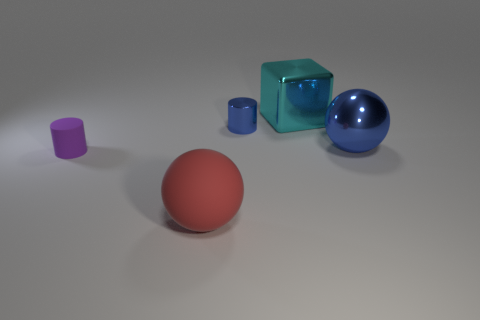There is a metallic thing in front of the tiny cylinder that is behind the large blue shiny object; what is its color?
Offer a terse response. Blue. Are there any green rubber balls?
Your answer should be very brief. No. There is a thing that is on the left side of the big cyan metal thing and behind the matte cylinder; what color is it?
Your answer should be very brief. Blue. There is a sphere right of the metal cube; does it have the same size as the blue thing that is to the left of the cyan metal block?
Your answer should be very brief. No. What number of other objects are there of the same size as the blue shiny cylinder?
Offer a terse response. 1. There is a matte object that is in front of the purple cylinder; what number of big cubes are on the left side of it?
Provide a succinct answer. 0. Is the number of large cyan blocks right of the blue metal ball less than the number of gray shiny objects?
Your answer should be very brief. No. What shape is the blue object behind the blue shiny object on the right side of the small thing behind the large blue object?
Offer a terse response. Cylinder. Is the shape of the purple matte object the same as the cyan metal object?
Keep it short and to the point. No. How many other objects are the same shape as the purple rubber thing?
Your response must be concise. 1. 